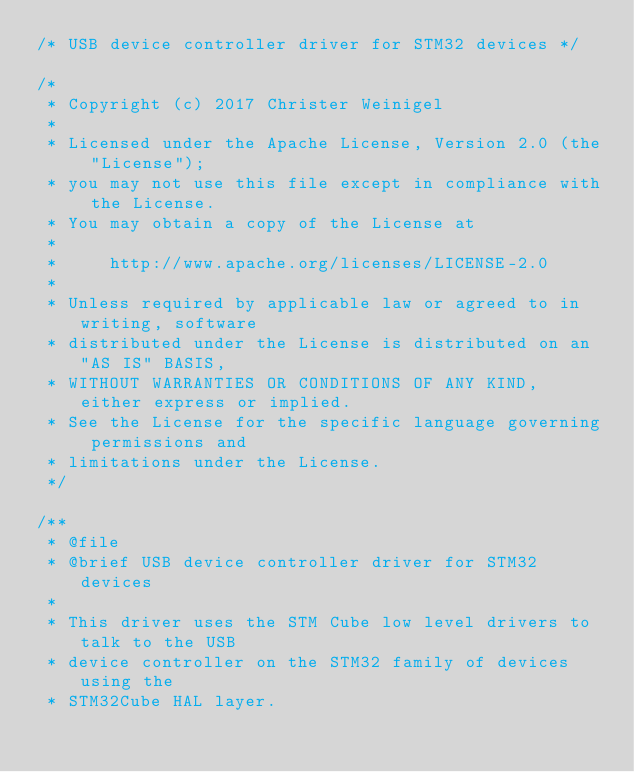<code> <loc_0><loc_0><loc_500><loc_500><_C_>/* USB device controller driver for STM32 devices */

/*
 * Copyright (c) 2017 Christer Weinigel
 *
 * Licensed under the Apache License, Version 2.0 (the "License");
 * you may not use this file except in compliance with the License.
 * You may obtain a copy of the License at
 *
 *     http://www.apache.org/licenses/LICENSE-2.0
 *
 * Unless required by applicable law or agreed to in writing, software
 * distributed under the License is distributed on an "AS IS" BASIS,
 * WITHOUT WARRANTIES OR CONDITIONS OF ANY KIND, either express or implied.
 * See the License for the specific language governing permissions and
 * limitations under the License.
 */

/**
 * @file
 * @brief USB device controller driver for STM32 devices
 *
 * This driver uses the STM Cube low level drivers to talk to the USB
 * device controller on the STM32 family of devices using the
 * STM32Cube HAL layer.</code> 